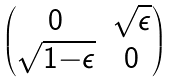<formula> <loc_0><loc_0><loc_500><loc_500>\begin{pmatrix} 0 & \sqrt { \epsilon } \\ \sqrt { 1 { - } \epsilon } & 0 \end{pmatrix}</formula> 